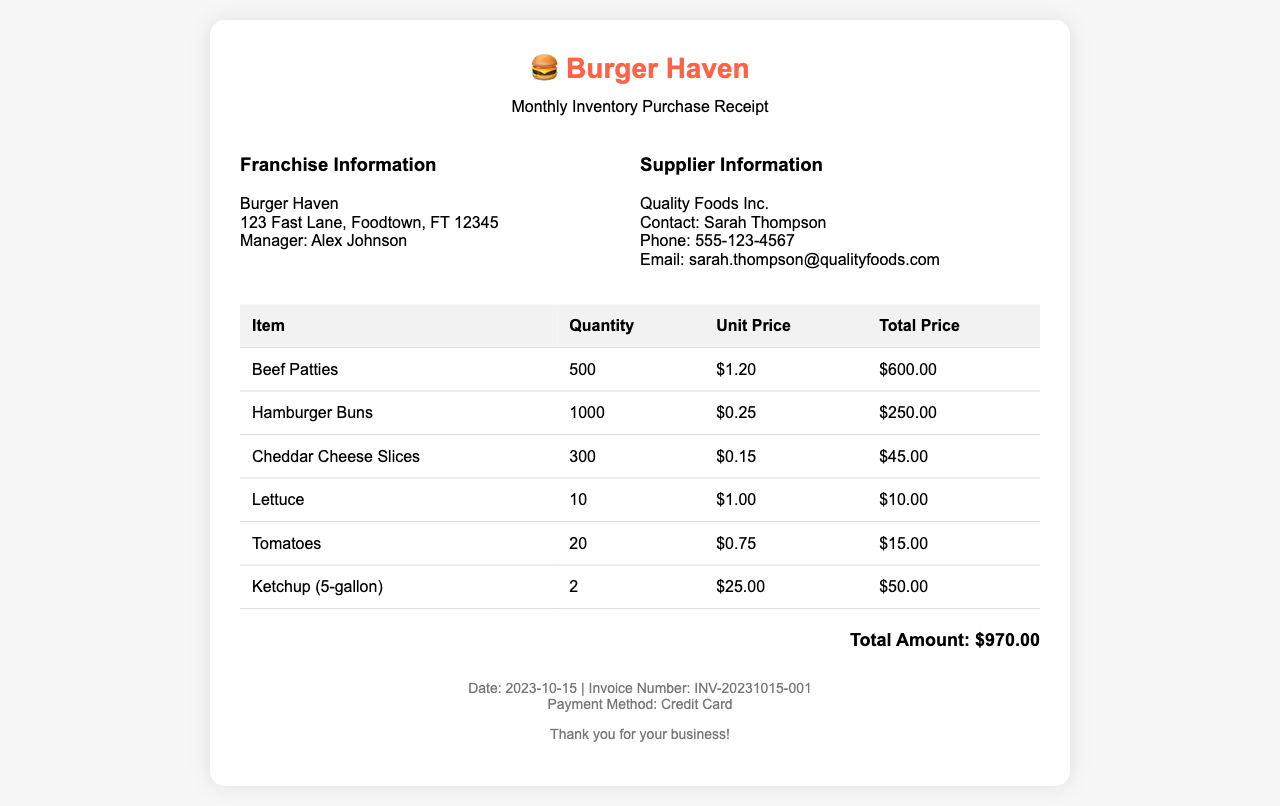What is the total amount of the receipt? The total amount is stated clearly at the bottom of the receipt.
Answer: $970.00 Who is the manager of Burger Haven? The manager's name is provided in the franchise information section.
Answer: Alex Johnson How many Beef Patties were purchased? The quantity of Beef Patties is listed in the itemized table on the receipt.
Answer: 500 What is the unit price of Hamburger Buns? The unit price for Hamburger Buns can be found in the itemized list in the document.
Answer: $0.25 What supplier is listed on the receipt? The supplier’s name is mentioned in the supplier information section of the receipt.
Answer: Quality Foods Inc How many tomatoes were ordered? The number of tomatoes is detailed in the table of inventory items.
Answer: 20 What is the payment method used for the transaction? The payment method is mentioned at the bottom of the receipt.
Answer: Credit Card What is the invoice number? The invoice number is provided as part of the date and payment information.
Answer: INV-20231015-001 What is the contact phone number for the supplier? The supplier's contact number is provided in the supplier information section.
Answer: 555-123-4567 